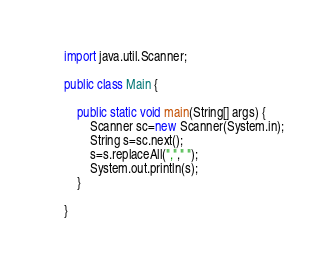<code> <loc_0><loc_0><loc_500><loc_500><_Java_>import java.util.Scanner;

public class Main {

	public static void main(String[] args) {
		Scanner sc=new Scanner(System.in);
		String s=sc.next();
		s=s.replaceAll(","," ");
		System.out.println(s);
	}

}
</code> 